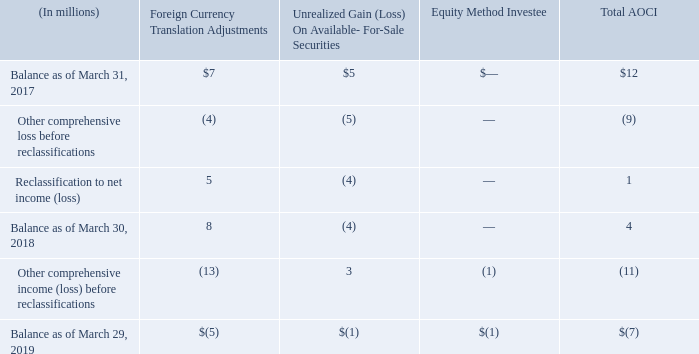Accumulated other comprehensive income (loss)
Components and activities of AOCI, net of tax, were as follows:
During fiscal 2018, a net foreign currency translation loss of $8 million related to foreign entities sold in the divestiture of our WSS and PKI solutions was reclassified to Gain on divestiture, and a net gain of $3 million related to liquidated foreign entities was reclassified to Other income (expense), net. A realized gain of $7 million on securities sold in connection with the divestiture of our WSS and PKI solutions was reclassified to Gain on divestiture. The tax effect of $3 million was reclassified to Income tax expense (benefit).
What does the table show? Components and activities of aoci, net of tax,. What units are used in the table? Millions. What is the Total AOCI  Balance as of March 31, 2017?
Answer scale should be: million. $12. As of March 31, 2017, what is the difference between the value of foreign currency translation adjustments and the unrealized gain on available-for-sale securities?  
Answer scale should be: million. 7-5
Answer: 2. What is the average balance as of the end of fiscal years 2017, 2018 and 2019 for Total AOCI?
Answer scale should be: million. (12+4+(-7))/3
Answer: 3. What is the  Other comprehensive income (loss) before reclassifications expressed as a percentage of  Balance as of March 29, 2019 for total AOCI?
Answer scale should be: percent. -11/-7
Answer: 157.14. 